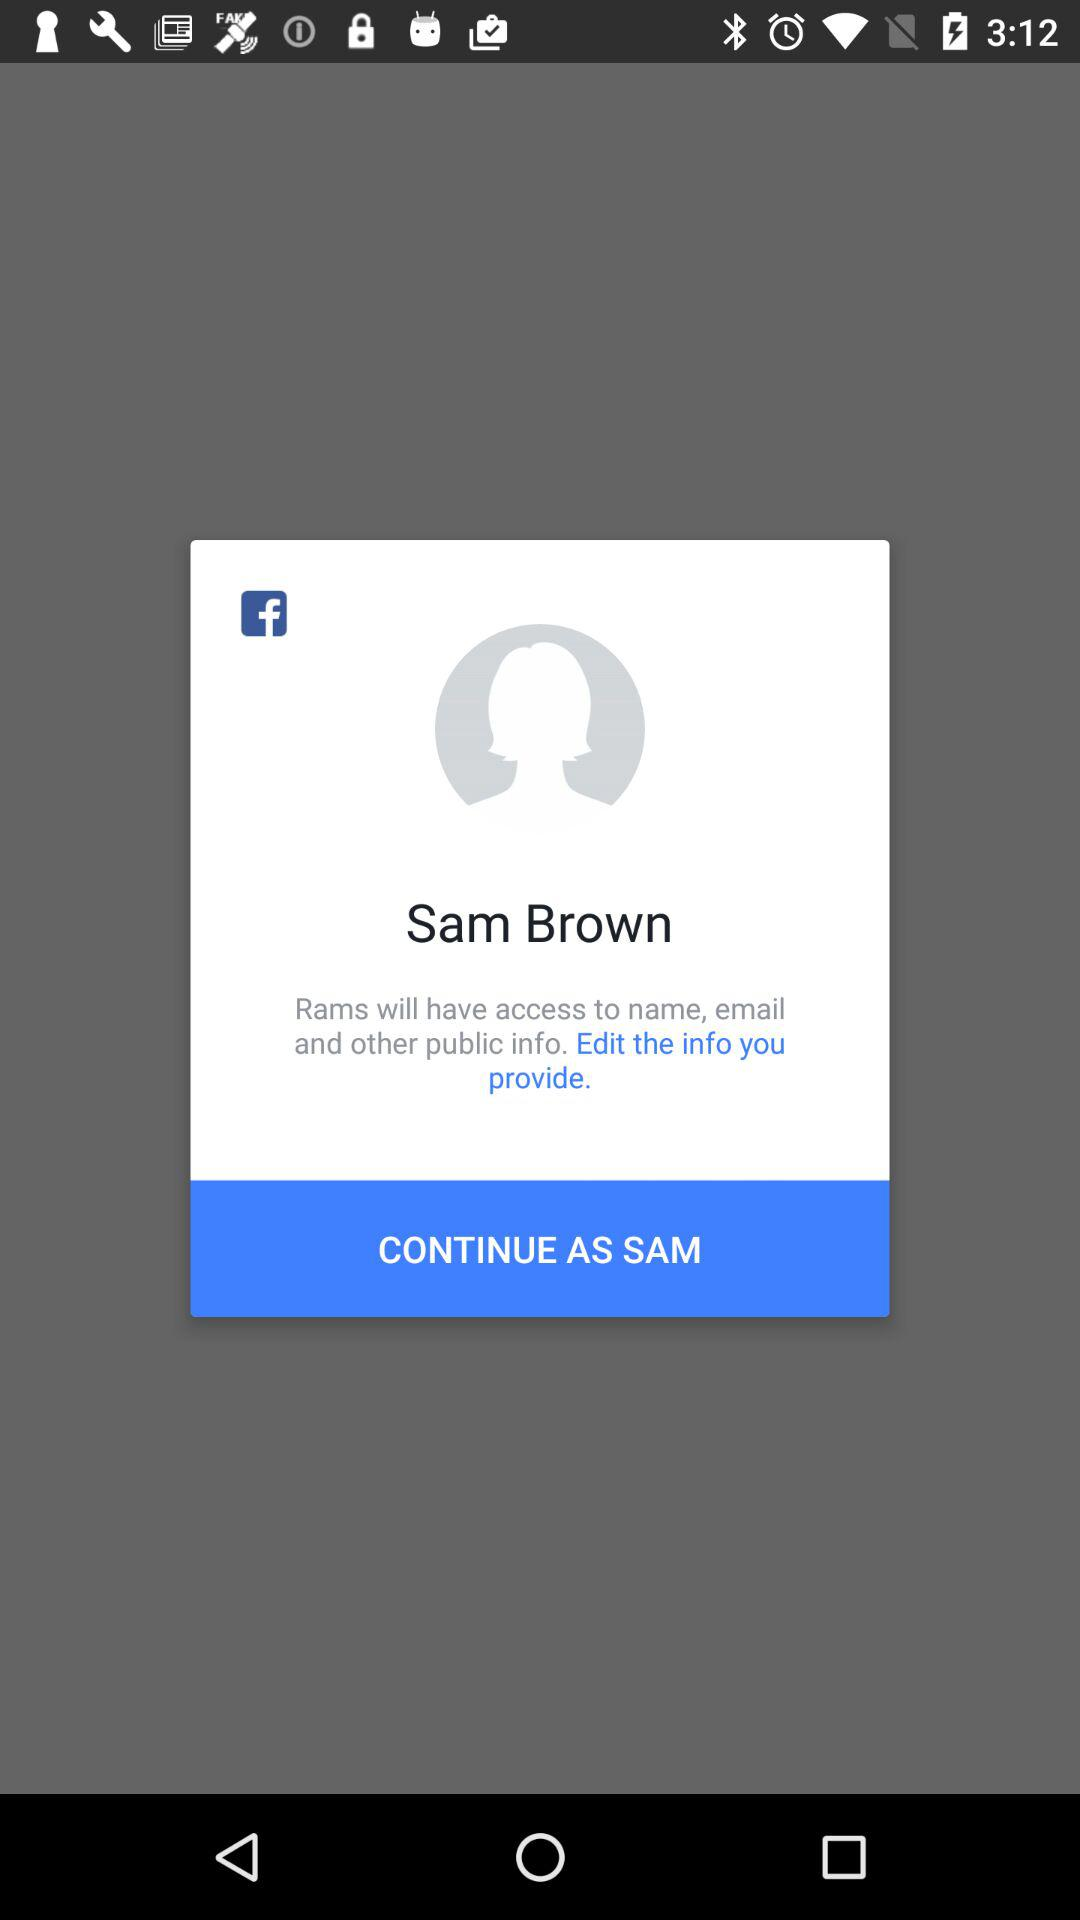What application is asking for permission? The application asking for permission is "Rams". 